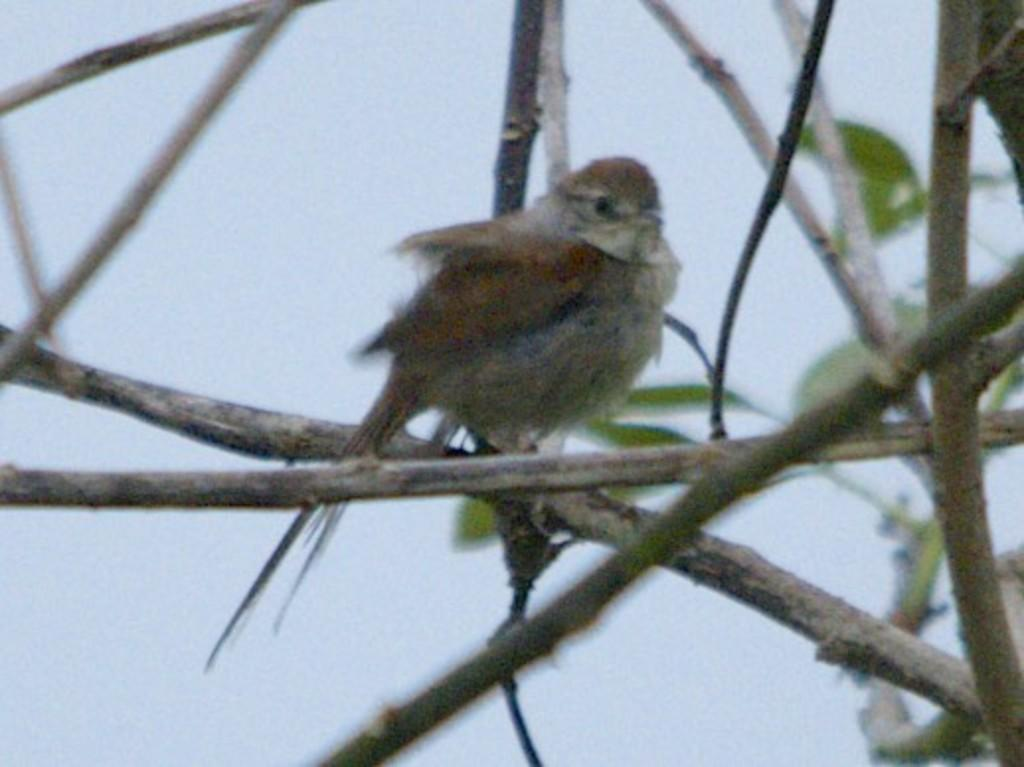What type of natural elements can be seen in the image? There are tree branches and leaves in the image. Is there any wildlife present in the image? Yes, there is a bird on one of the branches. What can be seen in the background of the image? The sky is visible in the background of the image. What type of canvas is being used to control the liquid in the image? There is no canvas or liquid present in the image; it features tree branches, leaves, and a bird. 